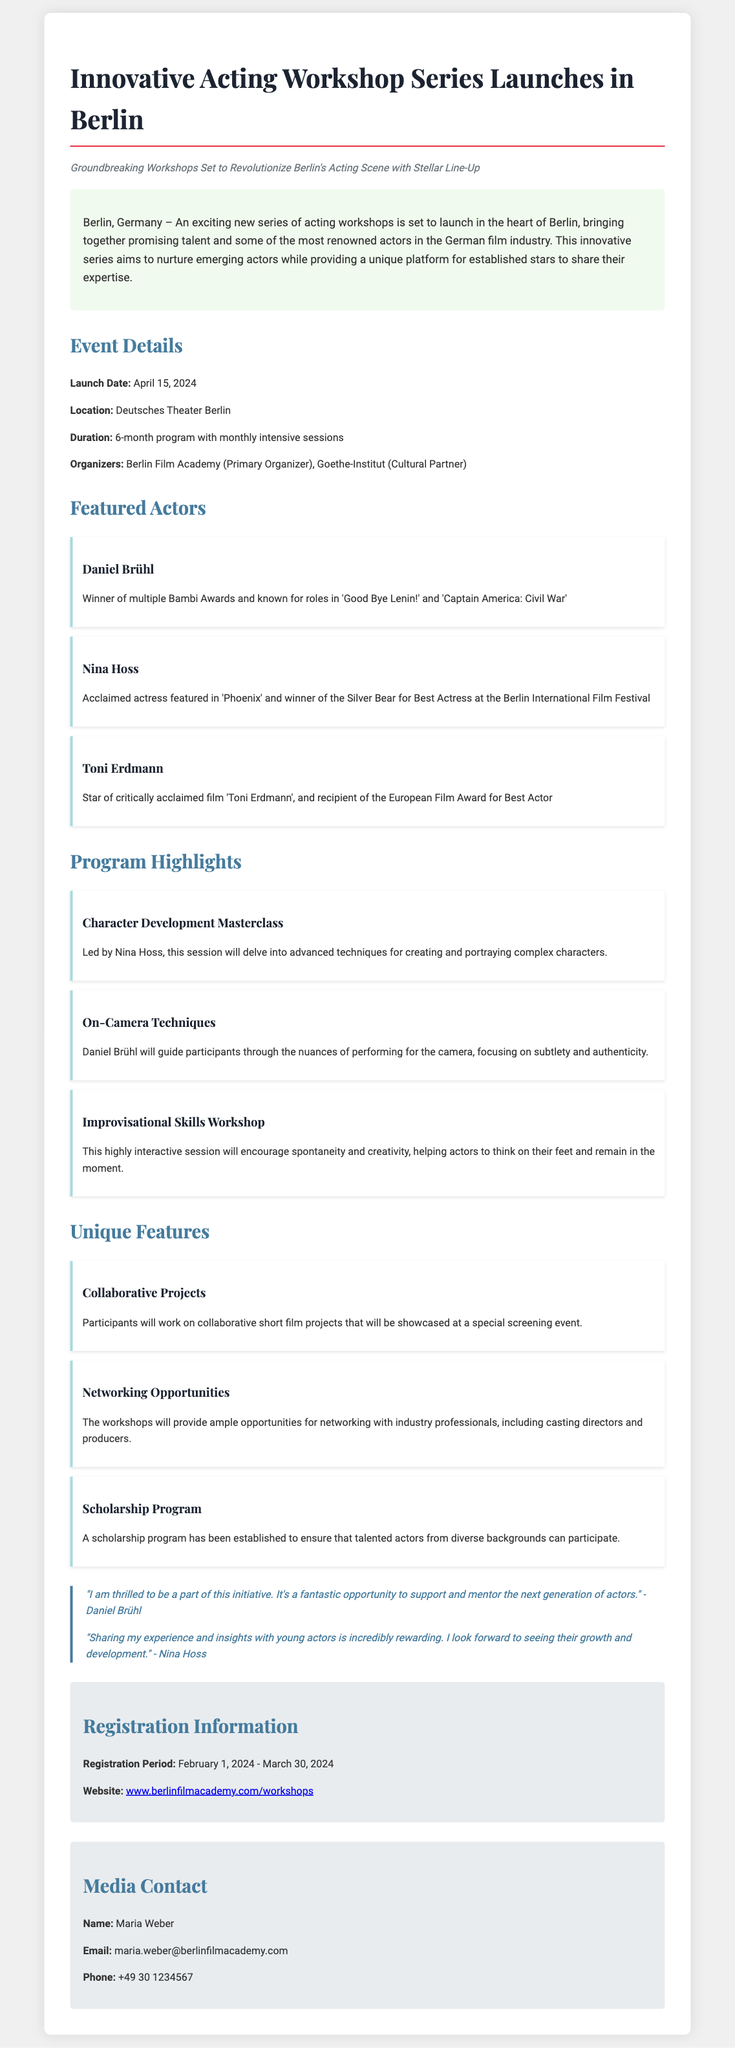what is the launch date of the workshop series? The document specifies that the launch date of the workshop series is April 15, 2024.
Answer: April 15, 2024 where will the workshops be held? According to the document, the workshops are set to take place at Deutsches Theater Berlin.
Answer: Deutsches Theater Berlin who are the primary organizers of the workshop series? The document lists the Berlin Film Academy as the primary organizer of the workshop series.
Answer: Berlin Film Academy how long is the duration of the program? The duration of the program is mentioned as a 6-month program with monthly intensive sessions.
Answer: 6-month program what type of opportunities will the workshops provide? The document states that the workshops will provide networking opportunities with industry professionals.
Answer: Networking opportunities which acclaimed actress is featured in the workshops? The document features Nina Hoss, known for her role in 'Phoenix' and having won the Silver Bear for Best Actress.
Answer: Nina Hoss what is one unique feature of the workshop series? The document highlights a scholarship program established to ensure participation from diverse backgrounds.
Answer: Scholarship program when is the registration period? The registration period is outlined in the document as February 1, 2024 - March 30, 2024.
Answer: February 1, 2024 - March 30, 2024 who should be contacted for media inquiries? The document provides Maria Weber as the contact person for media inquiries.
Answer: Maria Weber 